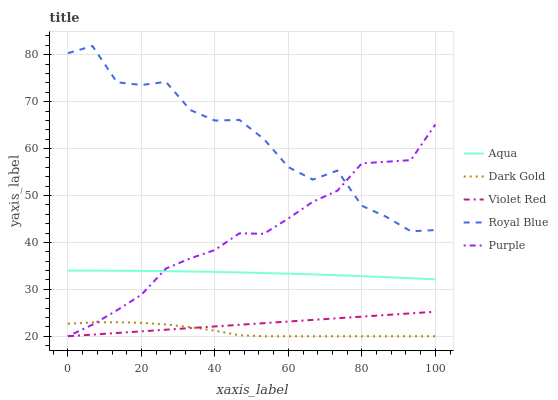Does Dark Gold have the minimum area under the curve?
Answer yes or no. Yes. Does Royal Blue have the maximum area under the curve?
Answer yes or no. Yes. Does Violet Red have the minimum area under the curve?
Answer yes or no. No. Does Violet Red have the maximum area under the curve?
Answer yes or no. No. Is Violet Red the smoothest?
Answer yes or no. Yes. Is Royal Blue the roughest?
Answer yes or no. Yes. Is Royal Blue the smoothest?
Answer yes or no. No. Is Violet Red the roughest?
Answer yes or no. No. Does Purple have the lowest value?
Answer yes or no. Yes. Does Royal Blue have the lowest value?
Answer yes or no. No. Does Royal Blue have the highest value?
Answer yes or no. Yes. Does Violet Red have the highest value?
Answer yes or no. No. Is Dark Gold less than Aqua?
Answer yes or no. Yes. Is Royal Blue greater than Aqua?
Answer yes or no. Yes. Does Royal Blue intersect Purple?
Answer yes or no. Yes. Is Royal Blue less than Purple?
Answer yes or no. No. Is Royal Blue greater than Purple?
Answer yes or no. No. Does Dark Gold intersect Aqua?
Answer yes or no. No. 